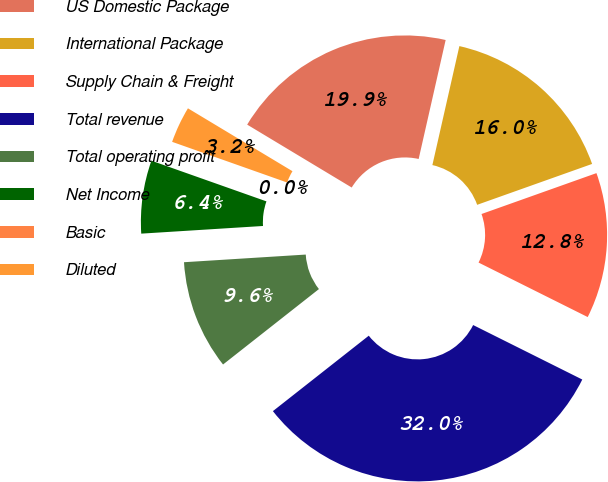Convert chart to OTSL. <chart><loc_0><loc_0><loc_500><loc_500><pie_chart><fcel>US Domestic Package<fcel>International Package<fcel>Supply Chain & Freight<fcel>Total revenue<fcel>Total operating profit<fcel>Net Income<fcel>Basic<fcel>Diluted<nl><fcel>19.93%<fcel>16.01%<fcel>12.81%<fcel>32.02%<fcel>9.61%<fcel>6.41%<fcel>0.0%<fcel>3.21%<nl></chart> 